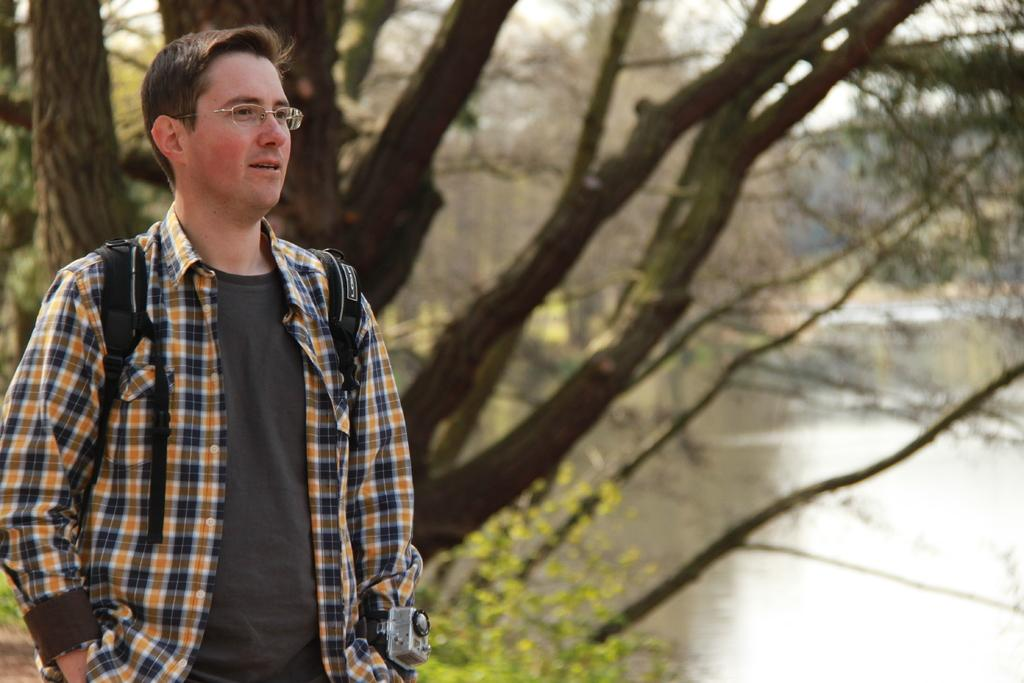Who is present in the image? There is a man in the image. What can be observed about the man's appearance? The man is wearing spectacles. What type of natural environment is visible in the background of the image? Trees, water, and the sky are visible in the background of the image. What type of bread is the man holding in the image? There is no bread present in the image. What does the man desire in the image? There is no indication of the man's desires in the image. 